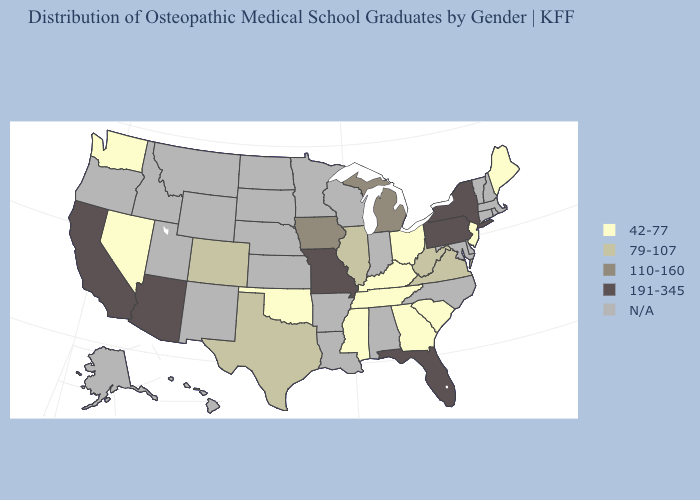Does Ohio have the lowest value in the MidWest?
Quick response, please. Yes. Which states have the highest value in the USA?
Keep it brief. Arizona, California, Florida, Missouri, New York, Pennsylvania. Name the states that have a value in the range 191-345?
Concise answer only. Arizona, California, Florida, Missouri, New York, Pennsylvania. What is the value of Texas?
Quick response, please. 79-107. What is the value of Maryland?
Give a very brief answer. N/A. What is the lowest value in states that border New Jersey?
Concise answer only. 191-345. Which states have the lowest value in the USA?
Answer briefly. Georgia, Kentucky, Maine, Mississippi, Nevada, New Jersey, Ohio, Oklahoma, South Carolina, Tennessee, Washington. How many symbols are there in the legend?
Quick response, please. 5. What is the lowest value in states that border New Jersey?
Concise answer only. 191-345. Name the states that have a value in the range N/A?
Give a very brief answer. Alabama, Alaska, Arkansas, Connecticut, Delaware, Hawaii, Idaho, Indiana, Kansas, Louisiana, Maryland, Massachusetts, Minnesota, Montana, Nebraska, New Hampshire, New Mexico, North Carolina, North Dakota, Oregon, Rhode Island, South Dakota, Utah, Vermont, Wisconsin, Wyoming. Does the first symbol in the legend represent the smallest category?
Keep it brief. Yes. What is the value of Alabama?
Concise answer only. N/A. 